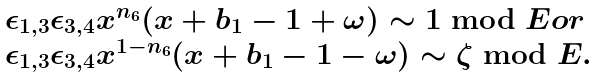Convert formula to latex. <formula><loc_0><loc_0><loc_500><loc_500>\begin{array} { l } \epsilon _ { 1 , 3 } \epsilon _ { 3 , 4 } x ^ { n _ { 6 } } ( x + b _ { 1 } - 1 + \omega ) \sim 1 \bmod E o r \\ \epsilon _ { 1 , 3 } \epsilon _ { 3 , 4 } x ^ { 1 - n _ { 6 } } ( x + b _ { 1 } - 1 - \omega ) \sim \zeta \bmod E . \\ \end{array}</formula> 